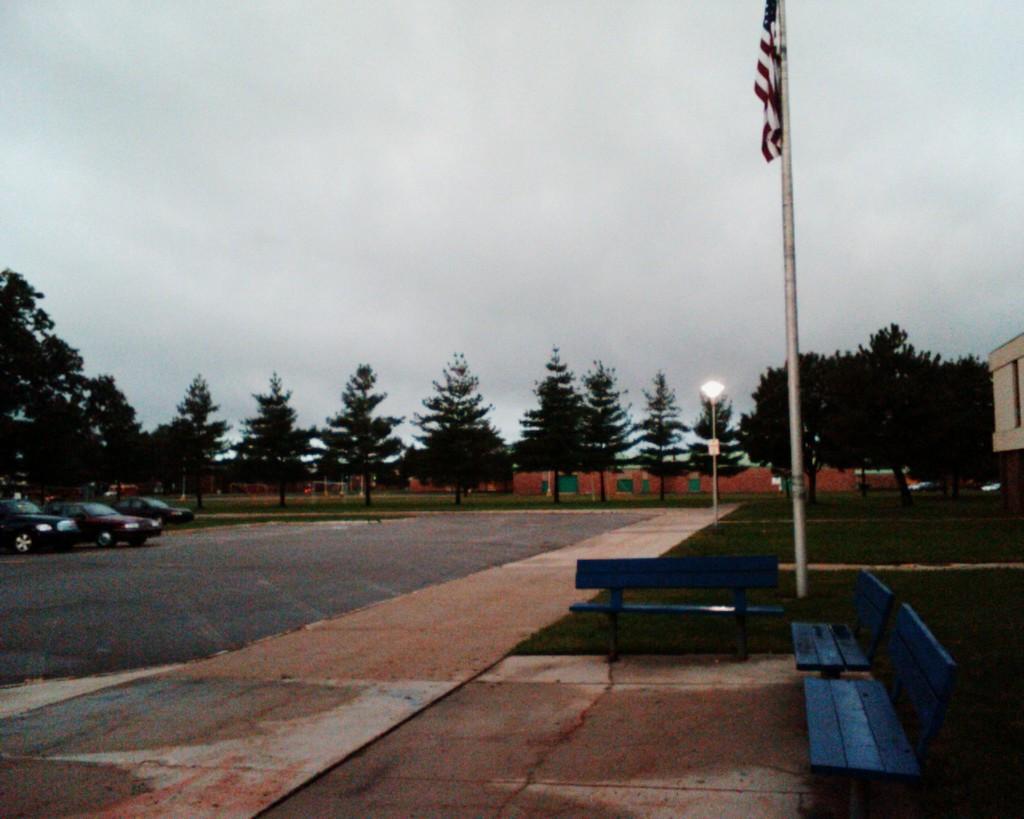Can you describe this image briefly? In this image I can see few vehicles on the road, trees. At right I can see a light pole, a flag in red, white and blue color. At right I can see a building in cream color, at top sky is in gray color. 